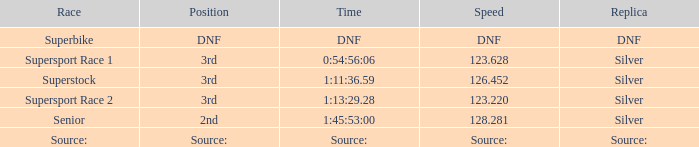452? Superstock. 